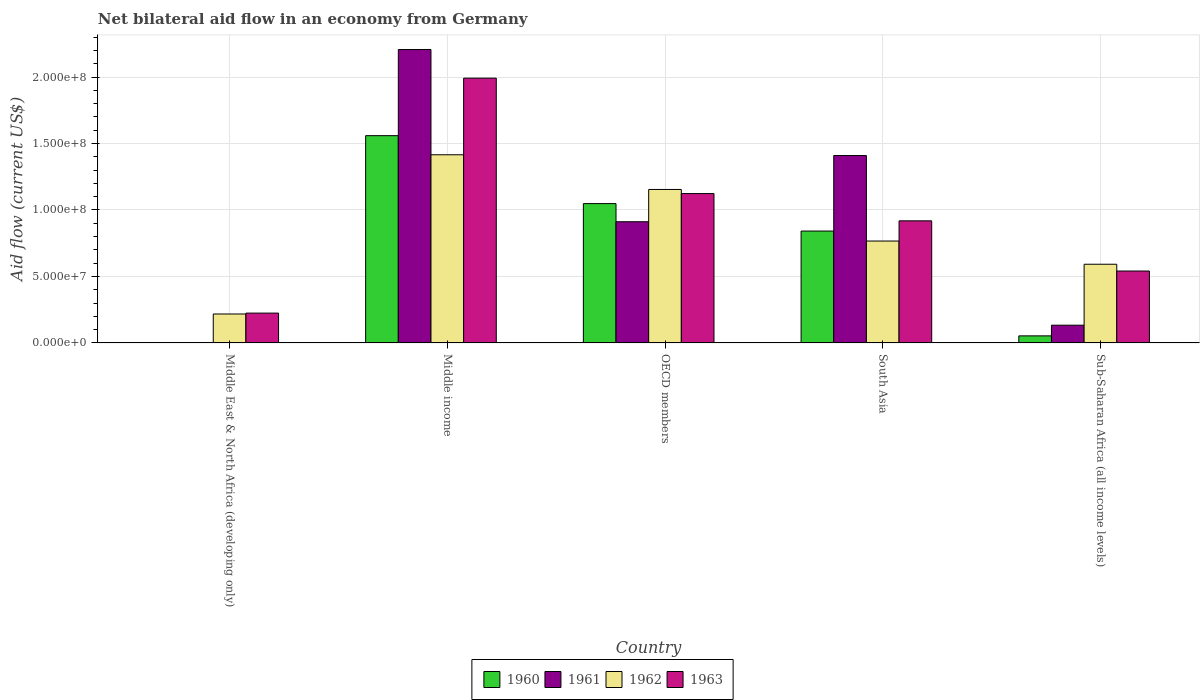Are the number of bars per tick equal to the number of legend labels?
Offer a terse response. No. Are the number of bars on each tick of the X-axis equal?
Your answer should be very brief. No. How many bars are there on the 1st tick from the left?
Make the answer very short. 2. How many bars are there on the 1st tick from the right?
Provide a short and direct response. 4. What is the label of the 3rd group of bars from the left?
Keep it short and to the point. OECD members. What is the net bilateral aid flow in 1962 in Sub-Saharan Africa (all income levels)?
Ensure brevity in your answer.  5.92e+07. Across all countries, what is the maximum net bilateral aid flow in 1963?
Give a very brief answer. 1.99e+08. Across all countries, what is the minimum net bilateral aid flow in 1963?
Your answer should be compact. 2.24e+07. What is the total net bilateral aid flow in 1961 in the graph?
Your answer should be compact. 4.66e+08. What is the difference between the net bilateral aid flow in 1962 in Middle East & North Africa (developing only) and that in Middle income?
Offer a terse response. -1.20e+08. What is the difference between the net bilateral aid flow in 1961 in OECD members and the net bilateral aid flow in 1963 in South Asia?
Your answer should be compact. -6.80e+05. What is the average net bilateral aid flow in 1962 per country?
Ensure brevity in your answer.  8.29e+07. What is the difference between the net bilateral aid flow of/in 1963 and net bilateral aid flow of/in 1961 in Sub-Saharan Africa (all income levels)?
Give a very brief answer. 4.07e+07. In how many countries, is the net bilateral aid flow in 1962 greater than 30000000 US$?
Your answer should be compact. 4. What is the ratio of the net bilateral aid flow in 1960 in Middle income to that in South Asia?
Provide a succinct answer. 1.85. What is the difference between the highest and the second highest net bilateral aid flow in 1960?
Give a very brief answer. 5.11e+07. What is the difference between the highest and the lowest net bilateral aid flow in 1960?
Your answer should be very brief. 1.56e+08. In how many countries, is the net bilateral aid flow in 1960 greater than the average net bilateral aid flow in 1960 taken over all countries?
Offer a very short reply. 3. Are all the bars in the graph horizontal?
Offer a very short reply. No. What is the difference between two consecutive major ticks on the Y-axis?
Provide a succinct answer. 5.00e+07. Are the values on the major ticks of Y-axis written in scientific E-notation?
Your answer should be very brief. Yes. Does the graph contain grids?
Give a very brief answer. Yes. How are the legend labels stacked?
Offer a terse response. Horizontal. What is the title of the graph?
Your answer should be very brief. Net bilateral aid flow in an economy from Germany. Does "1979" appear as one of the legend labels in the graph?
Provide a succinct answer. No. What is the label or title of the X-axis?
Your response must be concise. Country. What is the Aid flow (current US$) in 1960 in Middle East & North Africa (developing only)?
Provide a short and direct response. 0. What is the Aid flow (current US$) in 1961 in Middle East & North Africa (developing only)?
Make the answer very short. 0. What is the Aid flow (current US$) of 1962 in Middle East & North Africa (developing only)?
Your answer should be very brief. 2.18e+07. What is the Aid flow (current US$) of 1963 in Middle East & North Africa (developing only)?
Offer a very short reply. 2.24e+07. What is the Aid flow (current US$) of 1960 in Middle income?
Offer a very short reply. 1.56e+08. What is the Aid flow (current US$) of 1961 in Middle income?
Give a very brief answer. 2.21e+08. What is the Aid flow (current US$) of 1962 in Middle income?
Offer a very short reply. 1.42e+08. What is the Aid flow (current US$) of 1963 in Middle income?
Your response must be concise. 1.99e+08. What is the Aid flow (current US$) in 1960 in OECD members?
Provide a succinct answer. 1.05e+08. What is the Aid flow (current US$) in 1961 in OECD members?
Ensure brevity in your answer.  9.12e+07. What is the Aid flow (current US$) of 1962 in OECD members?
Your answer should be very brief. 1.15e+08. What is the Aid flow (current US$) of 1963 in OECD members?
Offer a terse response. 1.12e+08. What is the Aid flow (current US$) of 1960 in South Asia?
Give a very brief answer. 8.42e+07. What is the Aid flow (current US$) in 1961 in South Asia?
Offer a terse response. 1.41e+08. What is the Aid flow (current US$) in 1962 in South Asia?
Keep it short and to the point. 7.66e+07. What is the Aid flow (current US$) of 1963 in South Asia?
Make the answer very short. 9.18e+07. What is the Aid flow (current US$) of 1960 in Sub-Saharan Africa (all income levels)?
Your response must be concise. 5.32e+06. What is the Aid flow (current US$) of 1961 in Sub-Saharan Africa (all income levels)?
Give a very brief answer. 1.34e+07. What is the Aid flow (current US$) in 1962 in Sub-Saharan Africa (all income levels)?
Provide a short and direct response. 5.92e+07. What is the Aid flow (current US$) in 1963 in Sub-Saharan Africa (all income levels)?
Your answer should be compact. 5.41e+07. Across all countries, what is the maximum Aid flow (current US$) in 1960?
Keep it short and to the point. 1.56e+08. Across all countries, what is the maximum Aid flow (current US$) of 1961?
Your response must be concise. 2.21e+08. Across all countries, what is the maximum Aid flow (current US$) of 1962?
Give a very brief answer. 1.42e+08. Across all countries, what is the maximum Aid flow (current US$) of 1963?
Ensure brevity in your answer.  1.99e+08. Across all countries, what is the minimum Aid flow (current US$) of 1960?
Make the answer very short. 0. Across all countries, what is the minimum Aid flow (current US$) of 1961?
Provide a succinct answer. 0. Across all countries, what is the minimum Aid flow (current US$) of 1962?
Ensure brevity in your answer.  2.18e+07. Across all countries, what is the minimum Aid flow (current US$) of 1963?
Keep it short and to the point. 2.24e+07. What is the total Aid flow (current US$) of 1960 in the graph?
Give a very brief answer. 3.50e+08. What is the total Aid flow (current US$) of 1961 in the graph?
Keep it short and to the point. 4.66e+08. What is the total Aid flow (current US$) in 1962 in the graph?
Give a very brief answer. 4.15e+08. What is the total Aid flow (current US$) in 1963 in the graph?
Offer a terse response. 4.80e+08. What is the difference between the Aid flow (current US$) in 1962 in Middle East & North Africa (developing only) and that in Middle income?
Your answer should be compact. -1.20e+08. What is the difference between the Aid flow (current US$) in 1963 in Middle East & North Africa (developing only) and that in Middle income?
Your answer should be very brief. -1.77e+08. What is the difference between the Aid flow (current US$) in 1962 in Middle East & North Africa (developing only) and that in OECD members?
Provide a short and direct response. -9.37e+07. What is the difference between the Aid flow (current US$) in 1963 in Middle East & North Africa (developing only) and that in OECD members?
Offer a terse response. -8.99e+07. What is the difference between the Aid flow (current US$) of 1962 in Middle East & North Africa (developing only) and that in South Asia?
Make the answer very short. -5.49e+07. What is the difference between the Aid flow (current US$) of 1963 in Middle East & North Africa (developing only) and that in South Asia?
Give a very brief answer. -6.94e+07. What is the difference between the Aid flow (current US$) of 1962 in Middle East & North Africa (developing only) and that in Sub-Saharan Africa (all income levels)?
Your answer should be compact. -3.74e+07. What is the difference between the Aid flow (current US$) of 1963 in Middle East & North Africa (developing only) and that in Sub-Saharan Africa (all income levels)?
Keep it short and to the point. -3.16e+07. What is the difference between the Aid flow (current US$) of 1960 in Middle income and that in OECD members?
Your answer should be compact. 5.11e+07. What is the difference between the Aid flow (current US$) of 1961 in Middle income and that in OECD members?
Ensure brevity in your answer.  1.30e+08. What is the difference between the Aid flow (current US$) in 1962 in Middle income and that in OECD members?
Provide a short and direct response. 2.61e+07. What is the difference between the Aid flow (current US$) of 1963 in Middle income and that in OECD members?
Your answer should be compact. 8.68e+07. What is the difference between the Aid flow (current US$) in 1960 in Middle income and that in South Asia?
Ensure brevity in your answer.  7.18e+07. What is the difference between the Aid flow (current US$) in 1961 in Middle income and that in South Asia?
Your answer should be very brief. 7.97e+07. What is the difference between the Aid flow (current US$) of 1962 in Middle income and that in South Asia?
Keep it short and to the point. 6.49e+07. What is the difference between the Aid flow (current US$) in 1963 in Middle income and that in South Asia?
Make the answer very short. 1.07e+08. What is the difference between the Aid flow (current US$) of 1960 in Middle income and that in Sub-Saharan Africa (all income levels)?
Give a very brief answer. 1.51e+08. What is the difference between the Aid flow (current US$) in 1961 in Middle income and that in Sub-Saharan Africa (all income levels)?
Offer a terse response. 2.07e+08. What is the difference between the Aid flow (current US$) in 1962 in Middle income and that in Sub-Saharan Africa (all income levels)?
Provide a short and direct response. 8.23e+07. What is the difference between the Aid flow (current US$) of 1963 in Middle income and that in Sub-Saharan Africa (all income levels)?
Your answer should be compact. 1.45e+08. What is the difference between the Aid flow (current US$) of 1960 in OECD members and that in South Asia?
Make the answer very short. 2.06e+07. What is the difference between the Aid flow (current US$) of 1961 in OECD members and that in South Asia?
Provide a short and direct response. -4.98e+07. What is the difference between the Aid flow (current US$) in 1962 in OECD members and that in South Asia?
Your answer should be compact. 3.88e+07. What is the difference between the Aid flow (current US$) of 1963 in OECD members and that in South Asia?
Ensure brevity in your answer.  2.05e+07. What is the difference between the Aid flow (current US$) in 1960 in OECD members and that in Sub-Saharan Africa (all income levels)?
Offer a terse response. 9.95e+07. What is the difference between the Aid flow (current US$) in 1961 in OECD members and that in Sub-Saharan Africa (all income levels)?
Your response must be concise. 7.78e+07. What is the difference between the Aid flow (current US$) of 1962 in OECD members and that in Sub-Saharan Africa (all income levels)?
Make the answer very short. 5.62e+07. What is the difference between the Aid flow (current US$) of 1963 in OECD members and that in Sub-Saharan Africa (all income levels)?
Provide a short and direct response. 5.83e+07. What is the difference between the Aid flow (current US$) of 1960 in South Asia and that in Sub-Saharan Africa (all income levels)?
Provide a succinct answer. 7.88e+07. What is the difference between the Aid flow (current US$) of 1961 in South Asia and that in Sub-Saharan Africa (all income levels)?
Make the answer very short. 1.28e+08. What is the difference between the Aid flow (current US$) in 1962 in South Asia and that in Sub-Saharan Africa (all income levels)?
Your answer should be very brief. 1.75e+07. What is the difference between the Aid flow (current US$) in 1963 in South Asia and that in Sub-Saharan Africa (all income levels)?
Your response must be concise. 3.78e+07. What is the difference between the Aid flow (current US$) in 1962 in Middle East & North Africa (developing only) and the Aid flow (current US$) in 1963 in Middle income?
Give a very brief answer. -1.77e+08. What is the difference between the Aid flow (current US$) in 1962 in Middle East & North Africa (developing only) and the Aid flow (current US$) in 1963 in OECD members?
Ensure brevity in your answer.  -9.06e+07. What is the difference between the Aid flow (current US$) in 1962 in Middle East & North Africa (developing only) and the Aid flow (current US$) in 1963 in South Asia?
Provide a short and direct response. -7.01e+07. What is the difference between the Aid flow (current US$) of 1962 in Middle East & North Africa (developing only) and the Aid flow (current US$) of 1963 in Sub-Saharan Africa (all income levels)?
Provide a succinct answer. -3.23e+07. What is the difference between the Aid flow (current US$) in 1960 in Middle income and the Aid flow (current US$) in 1961 in OECD members?
Make the answer very short. 6.48e+07. What is the difference between the Aid flow (current US$) in 1960 in Middle income and the Aid flow (current US$) in 1962 in OECD members?
Your response must be concise. 4.05e+07. What is the difference between the Aid flow (current US$) of 1960 in Middle income and the Aid flow (current US$) of 1963 in OECD members?
Your response must be concise. 4.36e+07. What is the difference between the Aid flow (current US$) of 1961 in Middle income and the Aid flow (current US$) of 1962 in OECD members?
Give a very brief answer. 1.05e+08. What is the difference between the Aid flow (current US$) in 1961 in Middle income and the Aid flow (current US$) in 1963 in OECD members?
Your response must be concise. 1.08e+08. What is the difference between the Aid flow (current US$) in 1962 in Middle income and the Aid flow (current US$) in 1963 in OECD members?
Ensure brevity in your answer.  2.92e+07. What is the difference between the Aid flow (current US$) in 1960 in Middle income and the Aid flow (current US$) in 1961 in South Asia?
Keep it short and to the point. 1.50e+07. What is the difference between the Aid flow (current US$) in 1960 in Middle income and the Aid flow (current US$) in 1962 in South Asia?
Provide a succinct answer. 7.93e+07. What is the difference between the Aid flow (current US$) of 1960 in Middle income and the Aid flow (current US$) of 1963 in South Asia?
Your answer should be very brief. 6.41e+07. What is the difference between the Aid flow (current US$) of 1961 in Middle income and the Aid flow (current US$) of 1962 in South Asia?
Provide a succinct answer. 1.44e+08. What is the difference between the Aid flow (current US$) of 1961 in Middle income and the Aid flow (current US$) of 1963 in South Asia?
Ensure brevity in your answer.  1.29e+08. What is the difference between the Aid flow (current US$) of 1962 in Middle income and the Aid flow (current US$) of 1963 in South Asia?
Your answer should be very brief. 4.97e+07. What is the difference between the Aid flow (current US$) in 1960 in Middle income and the Aid flow (current US$) in 1961 in Sub-Saharan Africa (all income levels)?
Offer a very short reply. 1.43e+08. What is the difference between the Aid flow (current US$) in 1960 in Middle income and the Aid flow (current US$) in 1962 in Sub-Saharan Africa (all income levels)?
Your answer should be very brief. 9.67e+07. What is the difference between the Aid flow (current US$) in 1960 in Middle income and the Aid flow (current US$) in 1963 in Sub-Saharan Africa (all income levels)?
Your response must be concise. 1.02e+08. What is the difference between the Aid flow (current US$) in 1961 in Middle income and the Aid flow (current US$) in 1962 in Sub-Saharan Africa (all income levels)?
Offer a very short reply. 1.61e+08. What is the difference between the Aid flow (current US$) of 1961 in Middle income and the Aid flow (current US$) of 1963 in Sub-Saharan Africa (all income levels)?
Give a very brief answer. 1.67e+08. What is the difference between the Aid flow (current US$) of 1962 in Middle income and the Aid flow (current US$) of 1963 in Sub-Saharan Africa (all income levels)?
Make the answer very short. 8.74e+07. What is the difference between the Aid flow (current US$) in 1960 in OECD members and the Aid flow (current US$) in 1961 in South Asia?
Offer a terse response. -3.62e+07. What is the difference between the Aid flow (current US$) of 1960 in OECD members and the Aid flow (current US$) of 1962 in South Asia?
Make the answer very short. 2.82e+07. What is the difference between the Aid flow (current US$) in 1960 in OECD members and the Aid flow (current US$) in 1963 in South Asia?
Offer a terse response. 1.30e+07. What is the difference between the Aid flow (current US$) of 1961 in OECD members and the Aid flow (current US$) of 1962 in South Asia?
Provide a short and direct response. 1.45e+07. What is the difference between the Aid flow (current US$) of 1961 in OECD members and the Aid flow (current US$) of 1963 in South Asia?
Your answer should be compact. -6.80e+05. What is the difference between the Aid flow (current US$) of 1962 in OECD members and the Aid flow (current US$) of 1963 in South Asia?
Keep it short and to the point. 2.36e+07. What is the difference between the Aid flow (current US$) in 1960 in OECD members and the Aid flow (current US$) in 1961 in Sub-Saharan Africa (all income levels)?
Ensure brevity in your answer.  9.14e+07. What is the difference between the Aid flow (current US$) in 1960 in OECD members and the Aid flow (current US$) in 1962 in Sub-Saharan Africa (all income levels)?
Your answer should be compact. 4.56e+07. What is the difference between the Aid flow (current US$) of 1960 in OECD members and the Aid flow (current US$) of 1963 in Sub-Saharan Africa (all income levels)?
Ensure brevity in your answer.  5.07e+07. What is the difference between the Aid flow (current US$) of 1961 in OECD members and the Aid flow (current US$) of 1962 in Sub-Saharan Africa (all income levels)?
Provide a succinct answer. 3.20e+07. What is the difference between the Aid flow (current US$) in 1961 in OECD members and the Aid flow (current US$) in 1963 in Sub-Saharan Africa (all income levels)?
Offer a very short reply. 3.71e+07. What is the difference between the Aid flow (current US$) in 1962 in OECD members and the Aid flow (current US$) in 1963 in Sub-Saharan Africa (all income levels)?
Provide a succinct answer. 6.14e+07. What is the difference between the Aid flow (current US$) in 1960 in South Asia and the Aid flow (current US$) in 1961 in Sub-Saharan Africa (all income levels)?
Make the answer very short. 7.08e+07. What is the difference between the Aid flow (current US$) in 1960 in South Asia and the Aid flow (current US$) in 1962 in Sub-Saharan Africa (all income levels)?
Keep it short and to the point. 2.50e+07. What is the difference between the Aid flow (current US$) of 1960 in South Asia and the Aid flow (current US$) of 1963 in Sub-Saharan Africa (all income levels)?
Provide a succinct answer. 3.01e+07. What is the difference between the Aid flow (current US$) in 1961 in South Asia and the Aid flow (current US$) in 1962 in Sub-Saharan Africa (all income levels)?
Provide a short and direct response. 8.18e+07. What is the difference between the Aid flow (current US$) of 1961 in South Asia and the Aid flow (current US$) of 1963 in Sub-Saharan Africa (all income levels)?
Give a very brief answer. 8.69e+07. What is the difference between the Aid flow (current US$) of 1962 in South Asia and the Aid flow (current US$) of 1963 in Sub-Saharan Africa (all income levels)?
Make the answer very short. 2.26e+07. What is the average Aid flow (current US$) in 1960 per country?
Give a very brief answer. 7.00e+07. What is the average Aid flow (current US$) of 1961 per country?
Ensure brevity in your answer.  9.32e+07. What is the average Aid flow (current US$) of 1962 per country?
Your answer should be very brief. 8.29e+07. What is the average Aid flow (current US$) of 1963 per country?
Make the answer very short. 9.60e+07. What is the difference between the Aid flow (current US$) in 1962 and Aid flow (current US$) in 1963 in Middle East & North Africa (developing only)?
Provide a short and direct response. -6.70e+05. What is the difference between the Aid flow (current US$) of 1960 and Aid flow (current US$) of 1961 in Middle income?
Your response must be concise. -6.48e+07. What is the difference between the Aid flow (current US$) of 1960 and Aid flow (current US$) of 1962 in Middle income?
Keep it short and to the point. 1.44e+07. What is the difference between the Aid flow (current US$) in 1960 and Aid flow (current US$) in 1963 in Middle income?
Your answer should be very brief. -4.33e+07. What is the difference between the Aid flow (current US$) of 1961 and Aid flow (current US$) of 1962 in Middle income?
Your answer should be very brief. 7.92e+07. What is the difference between the Aid flow (current US$) in 1961 and Aid flow (current US$) in 1963 in Middle income?
Make the answer very short. 2.15e+07. What is the difference between the Aid flow (current US$) of 1962 and Aid flow (current US$) of 1963 in Middle income?
Give a very brief answer. -5.76e+07. What is the difference between the Aid flow (current US$) of 1960 and Aid flow (current US$) of 1961 in OECD members?
Give a very brief answer. 1.36e+07. What is the difference between the Aid flow (current US$) of 1960 and Aid flow (current US$) of 1962 in OECD members?
Offer a terse response. -1.06e+07. What is the difference between the Aid flow (current US$) of 1960 and Aid flow (current US$) of 1963 in OECD members?
Offer a terse response. -7.55e+06. What is the difference between the Aid flow (current US$) in 1961 and Aid flow (current US$) in 1962 in OECD members?
Your answer should be compact. -2.43e+07. What is the difference between the Aid flow (current US$) of 1961 and Aid flow (current US$) of 1963 in OECD members?
Provide a short and direct response. -2.12e+07. What is the difference between the Aid flow (current US$) of 1962 and Aid flow (current US$) of 1963 in OECD members?
Offer a very short reply. 3.09e+06. What is the difference between the Aid flow (current US$) in 1960 and Aid flow (current US$) in 1961 in South Asia?
Offer a terse response. -5.68e+07. What is the difference between the Aid flow (current US$) in 1960 and Aid flow (current US$) in 1962 in South Asia?
Give a very brief answer. 7.50e+06. What is the difference between the Aid flow (current US$) in 1960 and Aid flow (current US$) in 1963 in South Asia?
Ensure brevity in your answer.  -7.69e+06. What is the difference between the Aid flow (current US$) in 1961 and Aid flow (current US$) in 1962 in South Asia?
Provide a succinct answer. 6.43e+07. What is the difference between the Aid flow (current US$) of 1961 and Aid flow (current US$) of 1963 in South Asia?
Offer a very short reply. 4.91e+07. What is the difference between the Aid flow (current US$) of 1962 and Aid flow (current US$) of 1963 in South Asia?
Your response must be concise. -1.52e+07. What is the difference between the Aid flow (current US$) in 1960 and Aid flow (current US$) in 1961 in Sub-Saharan Africa (all income levels)?
Offer a very short reply. -8.03e+06. What is the difference between the Aid flow (current US$) of 1960 and Aid flow (current US$) of 1962 in Sub-Saharan Africa (all income levels)?
Your response must be concise. -5.39e+07. What is the difference between the Aid flow (current US$) of 1960 and Aid flow (current US$) of 1963 in Sub-Saharan Africa (all income levels)?
Your response must be concise. -4.88e+07. What is the difference between the Aid flow (current US$) in 1961 and Aid flow (current US$) in 1962 in Sub-Saharan Africa (all income levels)?
Keep it short and to the point. -4.58e+07. What is the difference between the Aid flow (current US$) of 1961 and Aid flow (current US$) of 1963 in Sub-Saharan Africa (all income levels)?
Your answer should be very brief. -4.07e+07. What is the difference between the Aid flow (current US$) of 1962 and Aid flow (current US$) of 1963 in Sub-Saharan Africa (all income levels)?
Keep it short and to the point. 5.10e+06. What is the ratio of the Aid flow (current US$) of 1962 in Middle East & North Africa (developing only) to that in Middle income?
Provide a succinct answer. 0.15. What is the ratio of the Aid flow (current US$) of 1963 in Middle East & North Africa (developing only) to that in Middle income?
Offer a terse response. 0.11. What is the ratio of the Aid flow (current US$) in 1962 in Middle East & North Africa (developing only) to that in OECD members?
Give a very brief answer. 0.19. What is the ratio of the Aid flow (current US$) of 1963 in Middle East & North Africa (developing only) to that in OECD members?
Provide a succinct answer. 0.2. What is the ratio of the Aid flow (current US$) in 1962 in Middle East & North Africa (developing only) to that in South Asia?
Provide a short and direct response. 0.28. What is the ratio of the Aid flow (current US$) of 1963 in Middle East & North Africa (developing only) to that in South Asia?
Your response must be concise. 0.24. What is the ratio of the Aid flow (current US$) in 1962 in Middle East & North Africa (developing only) to that in Sub-Saharan Africa (all income levels)?
Keep it short and to the point. 0.37. What is the ratio of the Aid flow (current US$) in 1963 in Middle East & North Africa (developing only) to that in Sub-Saharan Africa (all income levels)?
Your response must be concise. 0.41. What is the ratio of the Aid flow (current US$) in 1960 in Middle income to that in OECD members?
Your response must be concise. 1.49. What is the ratio of the Aid flow (current US$) in 1961 in Middle income to that in OECD members?
Give a very brief answer. 2.42. What is the ratio of the Aid flow (current US$) of 1962 in Middle income to that in OECD members?
Keep it short and to the point. 1.23. What is the ratio of the Aid flow (current US$) in 1963 in Middle income to that in OECD members?
Make the answer very short. 1.77. What is the ratio of the Aid flow (current US$) of 1960 in Middle income to that in South Asia?
Offer a very short reply. 1.85. What is the ratio of the Aid flow (current US$) of 1961 in Middle income to that in South Asia?
Provide a short and direct response. 1.57. What is the ratio of the Aid flow (current US$) of 1962 in Middle income to that in South Asia?
Make the answer very short. 1.85. What is the ratio of the Aid flow (current US$) in 1963 in Middle income to that in South Asia?
Your answer should be very brief. 2.17. What is the ratio of the Aid flow (current US$) in 1960 in Middle income to that in Sub-Saharan Africa (all income levels)?
Your answer should be compact. 29.31. What is the ratio of the Aid flow (current US$) of 1961 in Middle income to that in Sub-Saharan Africa (all income levels)?
Your response must be concise. 16.53. What is the ratio of the Aid flow (current US$) of 1962 in Middle income to that in Sub-Saharan Africa (all income levels)?
Ensure brevity in your answer.  2.39. What is the ratio of the Aid flow (current US$) of 1963 in Middle income to that in Sub-Saharan Africa (all income levels)?
Provide a short and direct response. 3.68. What is the ratio of the Aid flow (current US$) in 1960 in OECD members to that in South Asia?
Your answer should be very brief. 1.25. What is the ratio of the Aid flow (current US$) in 1961 in OECD members to that in South Asia?
Provide a short and direct response. 0.65. What is the ratio of the Aid flow (current US$) of 1962 in OECD members to that in South Asia?
Your answer should be very brief. 1.51. What is the ratio of the Aid flow (current US$) in 1963 in OECD members to that in South Asia?
Keep it short and to the point. 1.22. What is the ratio of the Aid flow (current US$) in 1960 in OECD members to that in Sub-Saharan Africa (all income levels)?
Keep it short and to the point. 19.7. What is the ratio of the Aid flow (current US$) of 1961 in OECD members to that in Sub-Saharan Africa (all income levels)?
Provide a short and direct response. 6.83. What is the ratio of the Aid flow (current US$) of 1962 in OECD members to that in Sub-Saharan Africa (all income levels)?
Provide a succinct answer. 1.95. What is the ratio of the Aid flow (current US$) of 1963 in OECD members to that in Sub-Saharan Africa (all income levels)?
Provide a short and direct response. 2.08. What is the ratio of the Aid flow (current US$) in 1960 in South Asia to that in Sub-Saharan Africa (all income levels)?
Your answer should be compact. 15.82. What is the ratio of the Aid flow (current US$) of 1961 in South Asia to that in Sub-Saharan Africa (all income levels)?
Offer a very short reply. 10.56. What is the ratio of the Aid flow (current US$) of 1962 in South Asia to that in Sub-Saharan Africa (all income levels)?
Provide a short and direct response. 1.29. What is the ratio of the Aid flow (current US$) in 1963 in South Asia to that in Sub-Saharan Africa (all income levels)?
Provide a succinct answer. 1.7. What is the difference between the highest and the second highest Aid flow (current US$) in 1960?
Your answer should be very brief. 5.11e+07. What is the difference between the highest and the second highest Aid flow (current US$) of 1961?
Give a very brief answer. 7.97e+07. What is the difference between the highest and the second highest Aid flow (current US$) of 1962?
Make the answer very short. 2.61e+07. What is the difference between the highest and the second highest Aid flow (current US$) of 1963?
Provide a succinct answer. 8.68e+07. What is the difference between the highest and the lowest Aid flow (current US$) of 1960?
Give a very brief answer. 1.56e+08. What is the difference between the highest and the lowest Aid flow (current US$) in 1961?
Your response must be concise. 2.21e+08. What is the difference between the highest and the lowest Aid flow (current US$) in 1962?
Provide a succinct answer. 1.20e+08. What is the difference between the highest and the lowest Aid flow (current US$) in 1963?
Provide a short and direct response. 1.77e+08. 